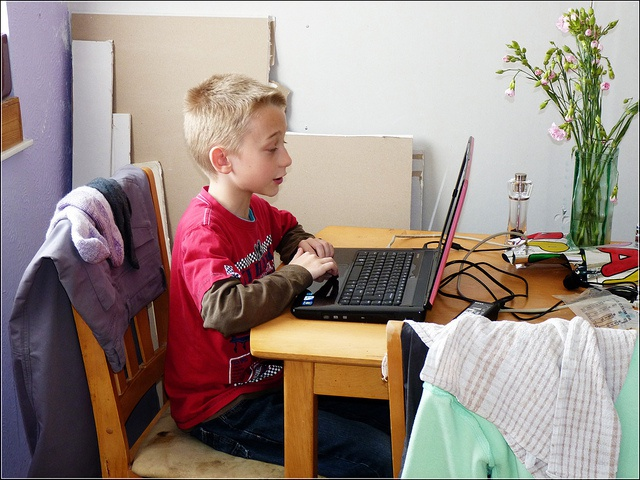Describe the objects in this image and their specific colors. I can see people in black, maroon, and tan tones, chair in black, maroon, brown, and gray tones, dining table in black, olive, khaki, and tan tones, laptop in black, gray, and darkgray tones, and vase in black, darkgreen, and gray tones in this image. 